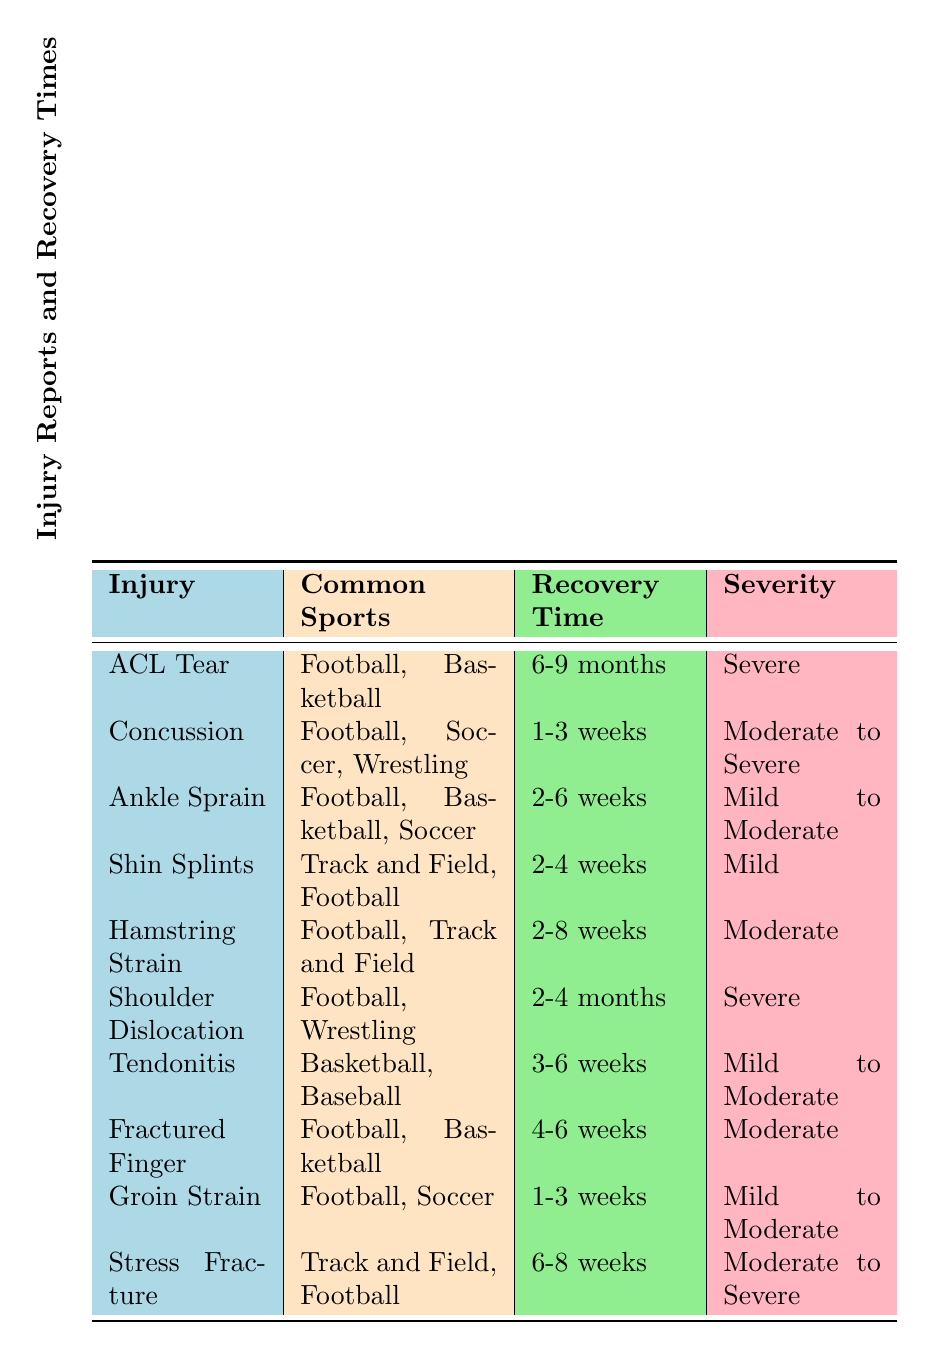What is the average recovery time for an ACL tear? The average recovery time for an ACL tear, as stated in the table, is "6-9 months."
Answer: 6-9 months Which injuries have a moderate severity rating? The injuries listed with a moderate severity rating are "Concussion," "Hamstring Strain," "Fractured Finger," and "Stress Fracture."
Answer: Concussion, Hamstring Strain, Fractured Finger, Stress Fracture Is "Tendonitis" common in Football? The common sports for "Tendonitis" are listed as "Basketball" and "Baseball," indicating it is not common in Football.
Answer: No How many injuries have a recovery time of 2-6 weeks? The injuries with a recovery time of 2-6 weeks are "Ankle Sprain," "Hamstring Strain," "Tendonitis," and "Fractured Finger." There are four injuries that fall into this category.
Answer: 4 What is the longest average recovery time among the injuries listed? The longest average recovery time among the listed injuries is for "ACL Tear" at 6-9 months. This is apparent as it is higher than others such as "Shoulder Dislocation" which is 2-4 months.
Answer: ACL Tear How many injuries are associated with Football? By counting from the "Common Sports" column, we find that there are six injuries associated with Football: "ACL Tear," "Concussion," "Ankle Sprain," "Shin Splints," "Hamstring Strain," and "Shoulder Dislocation," as well as both "Groin Strain" and "Stress Fracture."
Answer: 7 Which injury requires cognitive rest during rehabilitation? The injury that requires cognitive rest during rehabilitation is "Concussion," which is stated in the rehabilitation focus column.
Answer: Concussion Are all the injuries in the table considered severe? No, the table lists various severity ratings including "Mild," "Moderate," and "Severe." Both "Shin Splints" and "Ankle Sprain" are rated mild or moderate, which proves not all injuries are severe.
Answer: No 